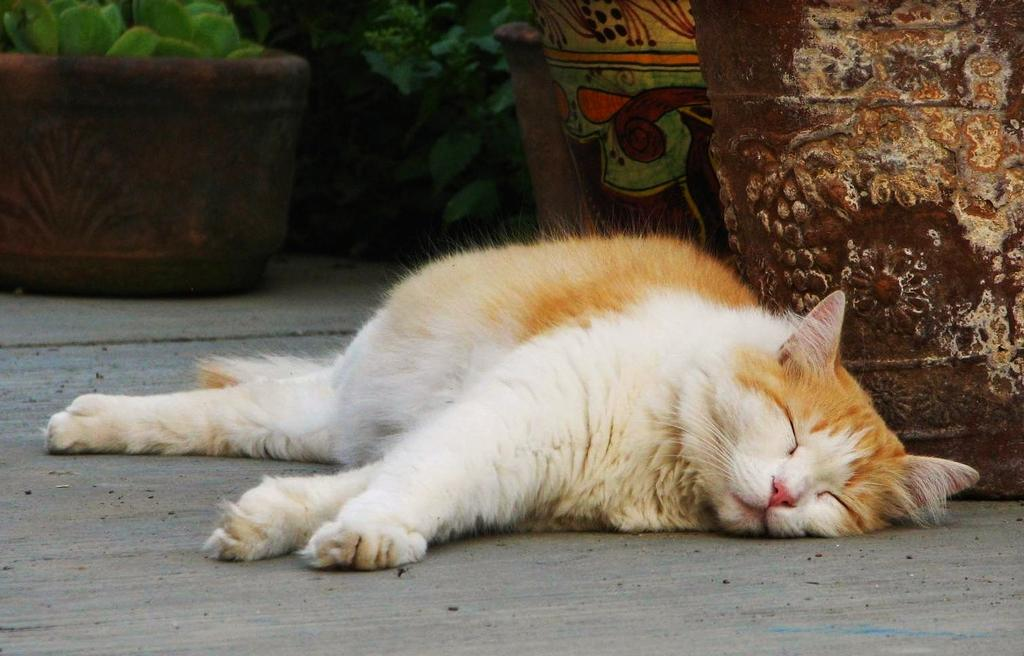What animal can be seen lying on the ground in the image? There is a cat lying on the ground in the image. What objects are present in the image besides the cat? There are pots in the image. What type of plant can be seen in the background of the image? There is a house plant in the background of the image. What type of produce is being harvested by the friends in the image? There are no friends or produce present in the image; it features a cat lying on the ground and pots. How many boats can be seen in the image? There are no boats present in the image. 